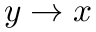Convert formula to latex. <formula><loc_0><loc_0><loc_500><loc_500>y \rightarrow x</formula> 